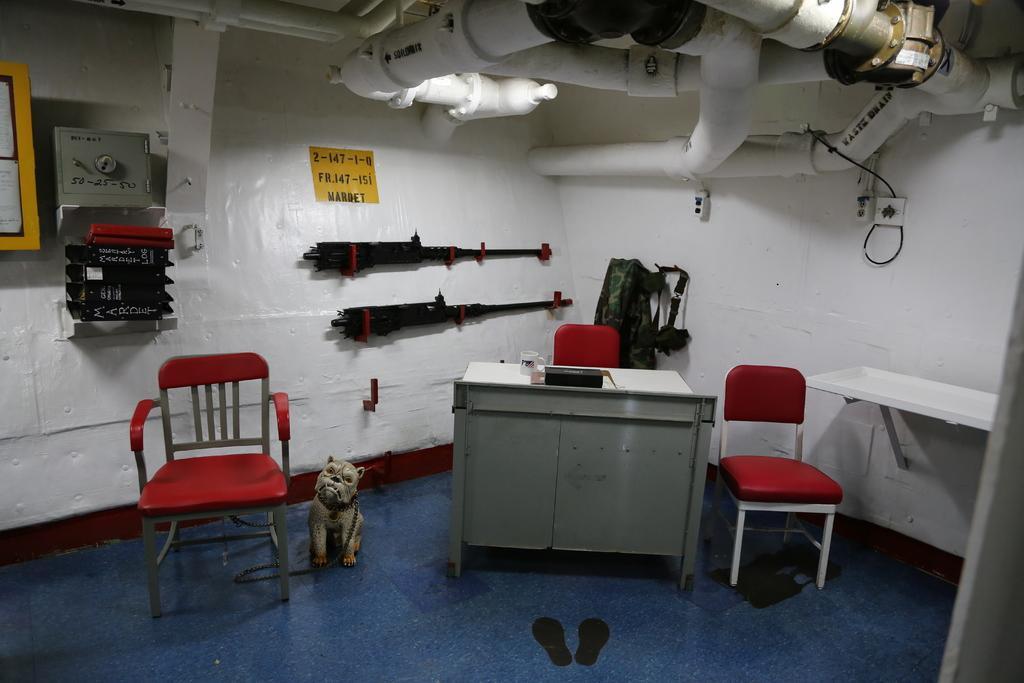Please provide a concise description of this image. In this picture we can see a few chairs on the floor. There is a dog tied with a chain to a chair on the left side. We can see a cup, box and other objects on the desk. We can see a few guns, bag, switchboards and other objects are visible on the wall. It seems like a footwear is on the ground. We can see a few pipes on top of the picture. 